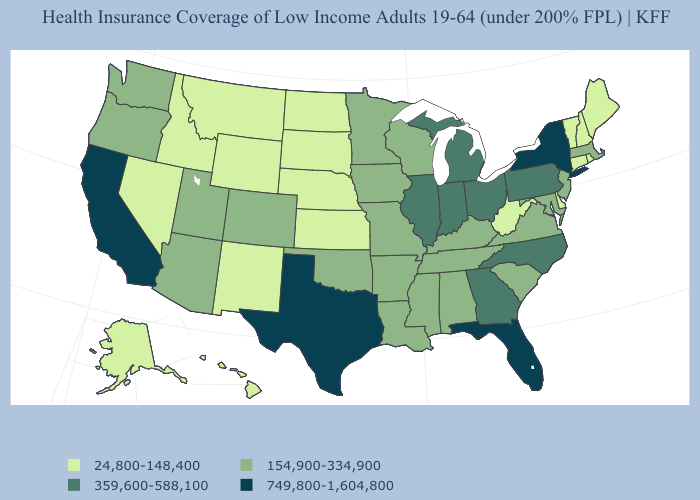Does North Dakota have the lowest value in the USA?
Short answer required. Yes. What is the value of Alaska?
Be succinct. 24,800-148,400. Name the states that have a value in the range 154,900-334,900?
Keep it brief. Alabama, Arizona, Arkansas, Colorado, Iowa, Kentucky, Louisiana, Maryland, Massachusetts, Minnesota, Mississippi, Missouri, New Jersey, Oklahoma, Oregon, South Carolina, Tennessee, Utah, Virginia, Washington, Wisconsin. Name the states that have a value in the range 749,800-1,604,800?
Give a very brief answer. California, Florida, New York, Texas. Does Missouri have the lowest value in the MidWest?
Short answer required. No. What is the highest value in the USA?
Be succinct. 749,800-1,604,800. Does New Jersey have the lowest value in the USA?
Write a very short answer. No. Does Idaho have a higher value than Indiana?
Quick response, please. No. Name the states that have a value in the range 24,800-148,400?
Quick response, please. Alaska, Connecticut, Delaware, Hawaii, Idaho, Kansas, Maine, Montana, Nebraska, Nevada, New Hampshire, New Mexico, North Dakota, Rhode Island, South Dakota, Vermont, West Virginia, Wyoming. Which states have the lowest value in the Northeast?
Short answer required. Connecticut, Maine, New Hampshire, Rhode Island, Vermont. Name the states that have a value in the range 749,800-1,604,800?
Keep it brief. California, Florida, New York, Texas. Does South Carolina have a higher value than New Hampshire?
Concise answer only. Yes. Name the states that have a value in the range 359,600-588,100?
Short answer required. Georgia, Illinois, Indiana, Michigan, North Carolina, Ohio, Pennsylvania. Name the states that have a value in the range 154,900-334,900?
Write a very short answer. Alabama, Arizona, Arkansas, Colorado, Iowa, Kentucky, Louisiana, Maryland, Massachusetts, Minnesota, Mississippi, Missouri, New Jersey, Oklahoma, Oregon, South Carolina, Tennessee, Utah, Virginia, Washington, Wisconsin. Name the states that have a value in the range 749,800-1,604,800?
Write a very short answer. California, Florida, New York, Texas. 